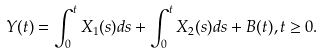Convert formula to latex. <formula><loc_0><loc_0><loc_500><loc_500>Y ( t ) = \int _ { 0 } ^ { t } X _ { 1 } ( s ) d s + \int _ { 0 } ^ { t } X _ { 2 } ( s ) d s + B ( t ) , t \geq 0 .</formula> 